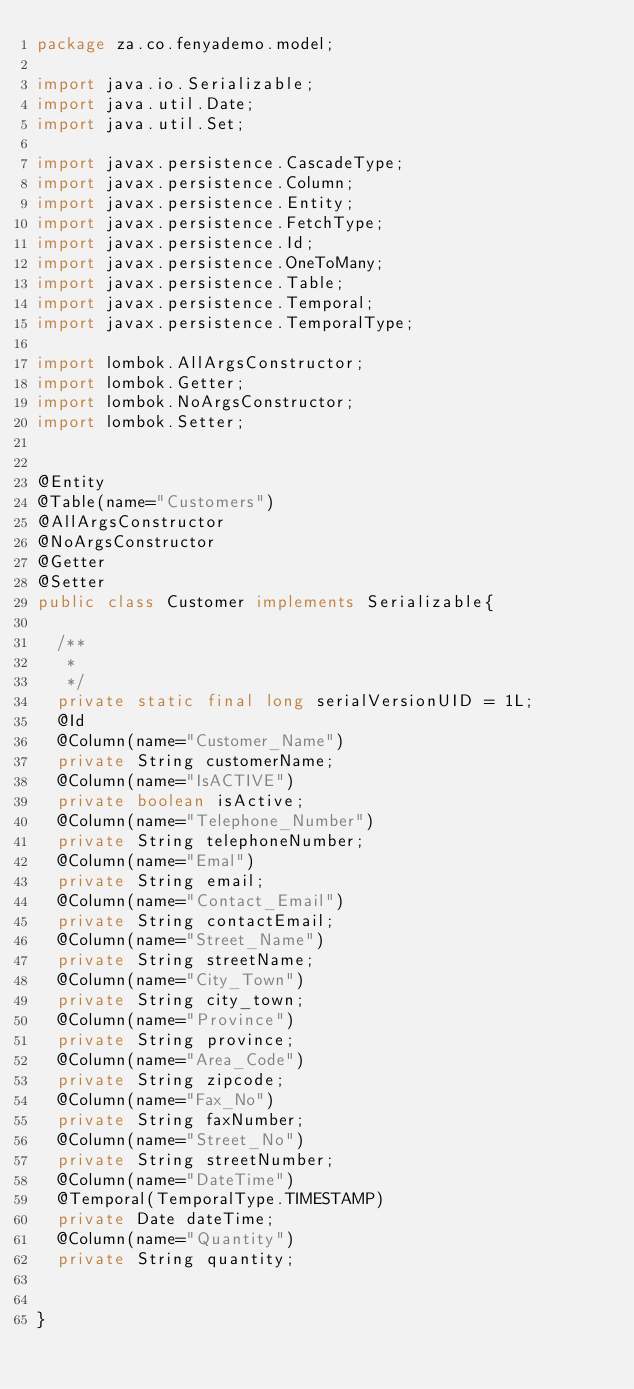<code> <loc_0><loc_0><loc_500><loc_500><_Java_>package za.co.fenyademo.model;

import java.io.Serializable;
import java.util.Date;
import java.util.Set;

import javax.persistence.CascadeType;
import javax.persistence.Column;
import javax.persistence.Entity;
import javax.persistence.FetchType;
import javax.persistence.Id;
import javax.persistence.OneToMany;
import javax.persistence.Table;
import javax.persistence.Temporal;
import javax.persistence.TemporalType;

import lombok.AllArgsConstructor;
import lombok.Getter;
import lombok.NoArgsConstructor;
import lombok.Setter;


@Entity
@Table(name="Customers")
@AllArgsConstructor
@NoArgsConstructor
@Getter
@Setter
public class Customer implements Serializable{

	/**
	 * 
	 */
	private static final long serialVersionUID = 1L;
	@Id
	@Column(name="Customer_Name")
	private String customerName;
	@Column(name="IsACTIVE")
	private boolean isActive;
	@Column(name="Telephone_Number")
	private String telephoneNumber;
	@Column(name="Emal")
	private String email;
	@Column(name="Contact_Email")
	private String contactEmail;
	@Column(name="Street_Name")
	private String streetName;
	@Column(name="City_Town")
	private String city_town;
	@Column(name="Province")
	private String province;
	@Column(name="Area_Code")
	private String zipcode;
	@Column(name="Fax_No")
	private String faxNumber;
	@Column(name="Street_No")
	private String streetNumber;
	@Column(name="DateTime")
	@Temporal(TemporalType.TIMESTAMP)
	private Date dateTime;
	@Column(name="Quantity")
	private String quantity;
	

}
</code> 